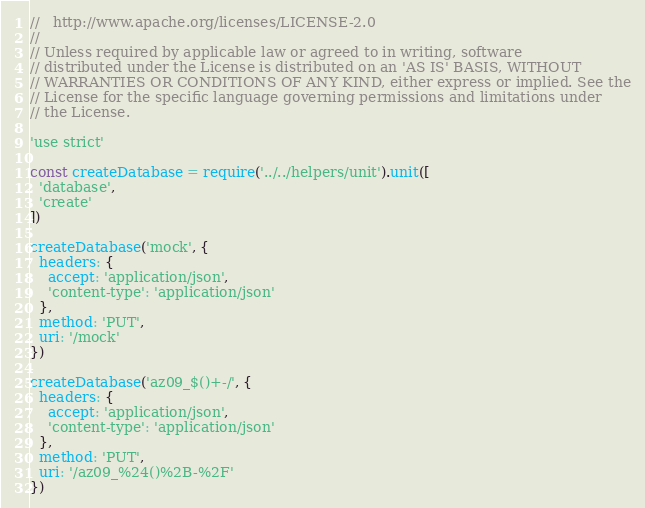Convert code to text. <code><loc_0><loc_0><loc_500><loc_500><_JavaScript_>//   http://www.apache.org/licenses/LICENSE-2.0
//
// Unless required by applicable law or agreed to in writing, software
// distributed under the License is distributed on an 'AS IS' BASIS, WITHOUT
// WARRANTIES OR CONDITIONS OF ANY KIND, either express or implied. See the
// License for the specific language governing permissions and limitations under
// the License.

'use strict'

const createDatabase = require('../../helpers/unit').unit([
  'database',
  'create'
])

createDatabase('mock', {
  headers: {
    accept: 'application/json',
    'content-type': 'application/json'
  },
  method: 'PUT',
  uri: '/mock'
})

createDatabase('az09_$()+-/', {
  headers: {
    accept: 'application/json',
    'content-type': 'application/json'
  },
  method: 'PUT',
  uri: '/az09_%24()%2B-%2F'
})
</code> 